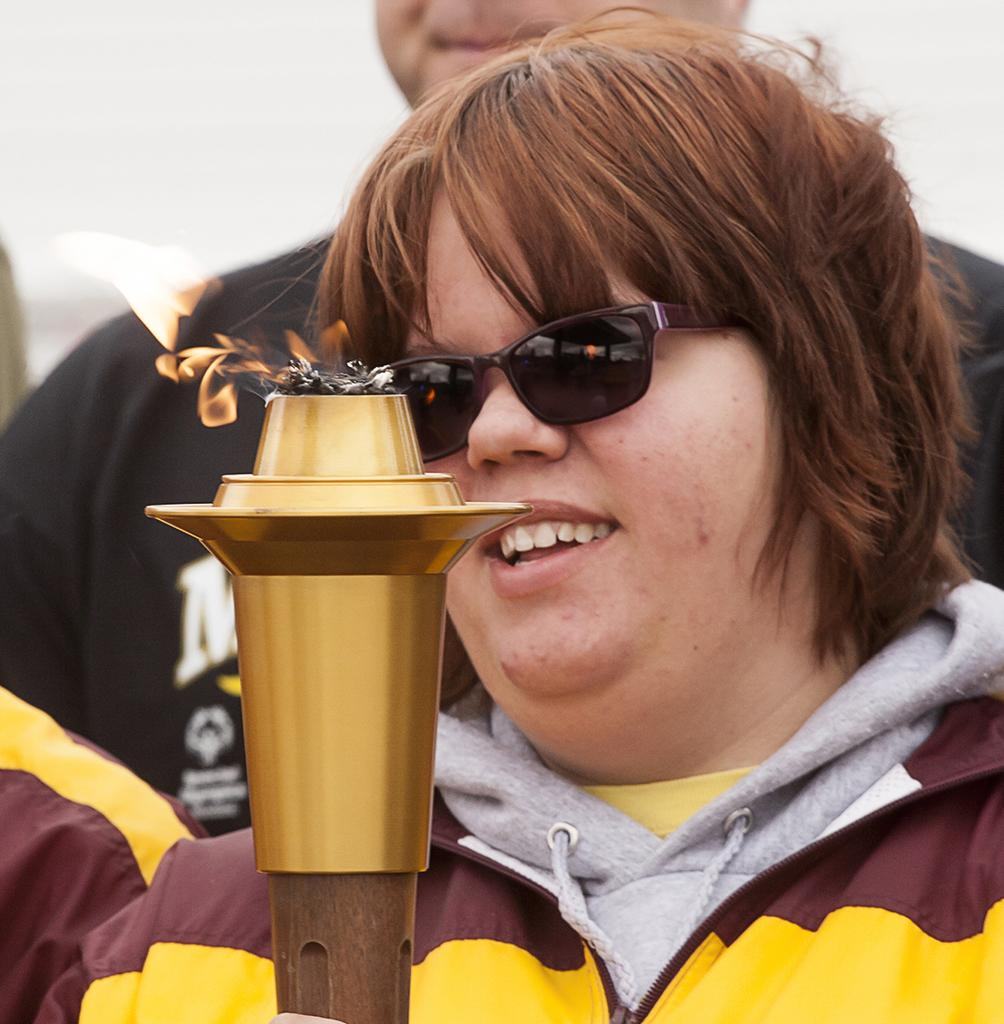What is the main subject of the image? There is a person standing in the middle of the image. What is the person holding in the image? The person is holding a fire pole. Are there any other people visible in the image? Yes, there are other people standing behind the person. What type of stamp can be seen on the cow in the image? There is no cow or stamp present in the image. How much change is visible on the ground near the person holding the fire pole? There is no mention of change or coins on the ground in the image. 